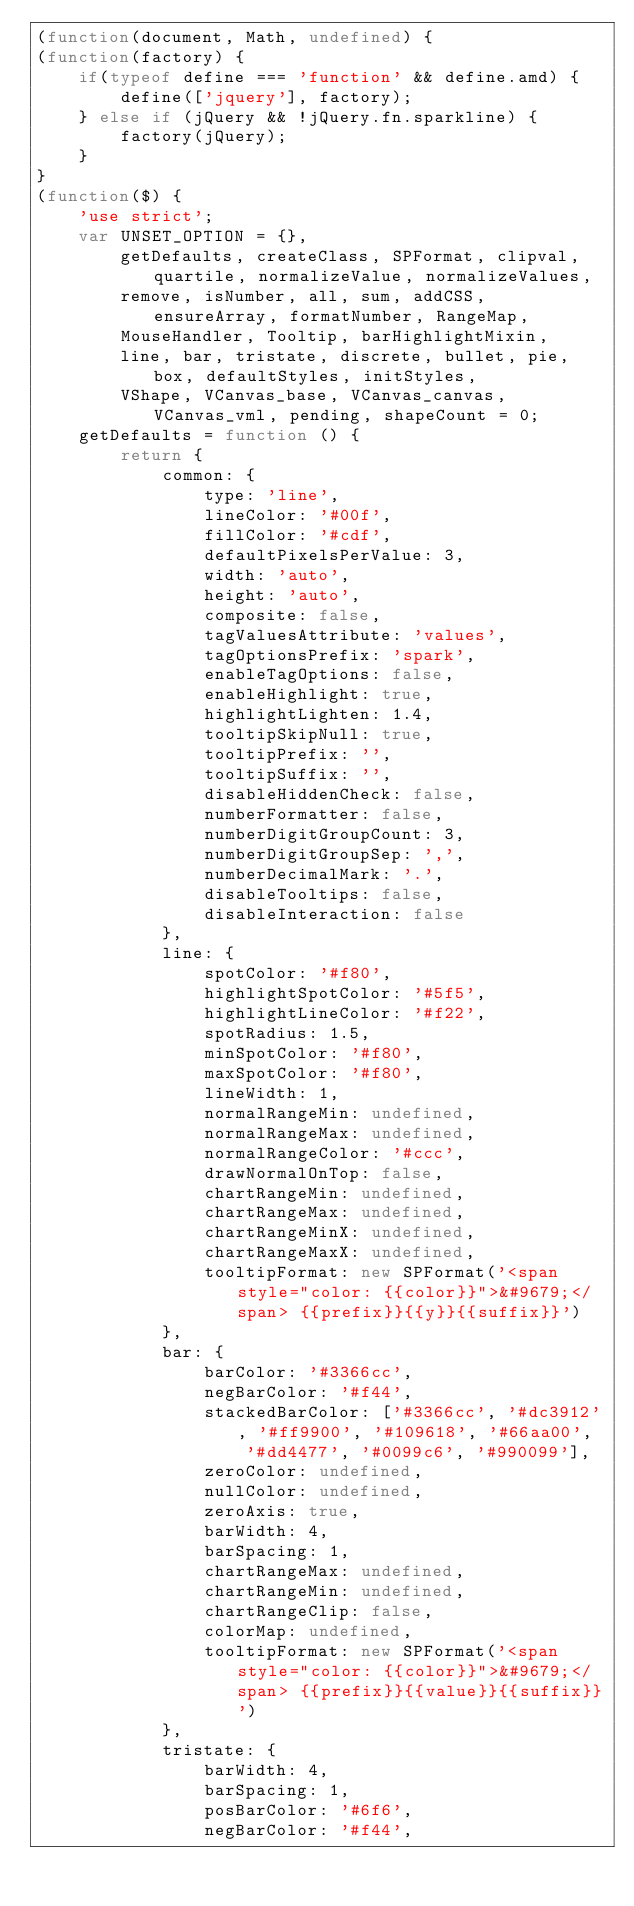Convert code to text. <code><loc_0><loc_0><loc_500><loc_500><_JavaScript_>(function(document, Math, undefined) { 
(function(factory) {
    if(typeof define === 'function' && define.amd) {
        define(['jquery'], factory);
    } else if (jQuery && !jQuery.fn.sparkline) {
        factory(jQuery);
    }
}
(function($) {
    'use strict';
    var UNSET_OPTION = {},
        getDefaults, createClass, SPFormat, clipval, quartile, normalizeValue, normalizeValues,
        remove, isNumber, all, sum, addCSS, ensureArray, formatNumber, RangeMap,
        MouseHandler, Tooltip, barHighlightMixin,
        line, bar, tristate, discrete, bullet, pie, box, defaultStyles, initStyles,
        VShape, VCanvas_base, VCanvas_canvas, VCanvas_vml, pending, shapeCount = 0;
    getDefaults = function () {
        return {
            common: {
                type: 'line',
                lineColor: '#00f',
                fillColor: '#cdf',
                defaultPixelsPerValue: 3,
                width: 'auto',
                height: 'auto',
                composite: false,
                tagValuesAttribute: 'values',
                tagOptionsPrefix: 'spark',
                enableTagOptions: false,
                enableHighlight: true,
                highlightLighten: 1.4,
                tooltipSkipNull: true,
                tooltipPrefix: '',
                tooltipSuffix: '',
                disableHiddenCheck: false,
                numberFormatter: false,
                numberDigitGroupCount: 3,
                numberDigitGroupSep: ',',
                numberDecimalMark: '.',
                disableTooltips: false,
                disableInteraction: false
            },
            line: {
                spotColor: '#f80',
                highlightSpotColor: '#5f5',
                highlightLineColor: '#f22',
                spotRadius: 1.5,
                minSpotColor: '#f80',
                maxSpotColor: '#f80',
                lineWidth: 1,
                normalRangeMin: undefined,
                normalRangeMax: undefined,
                normalRangeColor: '#ccc',
                drawNormalOnTop: false,
                chartRangeMin: undefined,
                chartRangeMax: undefined,
                chartRangeMinX: undefined,
                chartRangeMaxX: undefined,
                tooltipFormat: new SPFormat('<span style="color: {{color}}">&#9679;</span> {{prefix}}{{y}}{{suffix}}')
            },
            bar: {
                barColor: '#3366cc',
                negBarColor: '#f44',
                stackedBarColor: ['#3366cc', '#dc3912', '#ff9900', '#109618', '#66aa00',
                    '#dd4477', '#0099c6', '#990099'],
                zeroColor: undefined,
                nullColor: undefined,
                zeroAxis: true,
                barWidth: 4,
                barSpacing: 1,
                chartRangeMax: undefined,
                chartRangeMin: undefined,
                chartRangeClip: false,
                colorMap: undefined,
                tooltipFormat: new SPFormat('<span style="color: {{color}}">&#9679;</span> {{prefix}}{{value}}{{suffix}}')
            },
            tristate: {
                barWidth: 4,
                barSpacing: 1,
                posBarColor: '#6f6',
                negBarColor: '#f44',</code> 